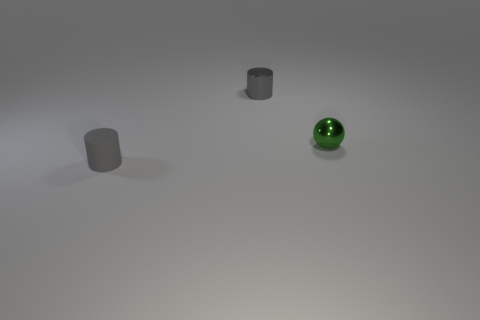Add 3 big cyan rubber cylinders. How many objects exist? 6 Subtract all balls. How many objects are left? 2 Subtract 1 balls. How many balls are left? 0 Subtract all green cylinders. Subtract all purple balls. How many cylinders are left? 2 Subtract all small gray objects. Subtract all small yellow rubber cubes. How many objects are left? 1 Add 1 cylinders. How many cylinders are left? 3 Add 2 small matte balls. How many small matte balls exist? 2 Subtract 0 red spheres. How many objects are left? 3 